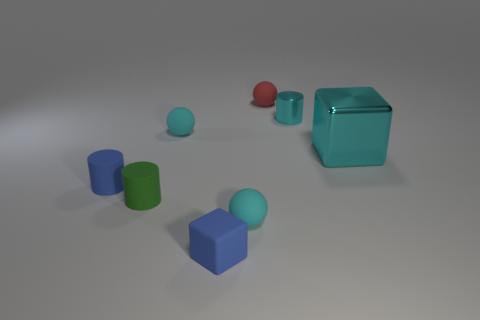Is there any other thing that is the same size as the blue cube?
Ensure brevity in your answer.  Yes. What shape is the large shiny object that is the same color as the small shiny cylinder?
Your response must be concise. Cube. What number of big purple matte objects are there?
Your answer should be compact. 0. Is the size of the blue block the same as the cyan metallic cube?
Make the answer very short. No. What number of other things are there of the same shape as the small metal object?
Provide a short and direct response. 2. What is the cylinder that is behind the cyan shiny object that is in front of the cyan cylinder made of?
Offer a terse response. Metal. Are there any cyan blocks to the right of the big cyan block?
Keep it short and to the point. No. There is a matte cube; is its size the same as the cyan matte sphere that is behind the blue cylinder?
Provide a succinct answer. Yes. What size is the blue rubber object that is the same shape as the small metal thing?
Provide a succinct answer. Small. Does the rubber cube that is in front of the tiny blue cylinder have the same size as the blue matte thing behind the small green thing?
Provide a succinct answer. Yes. 